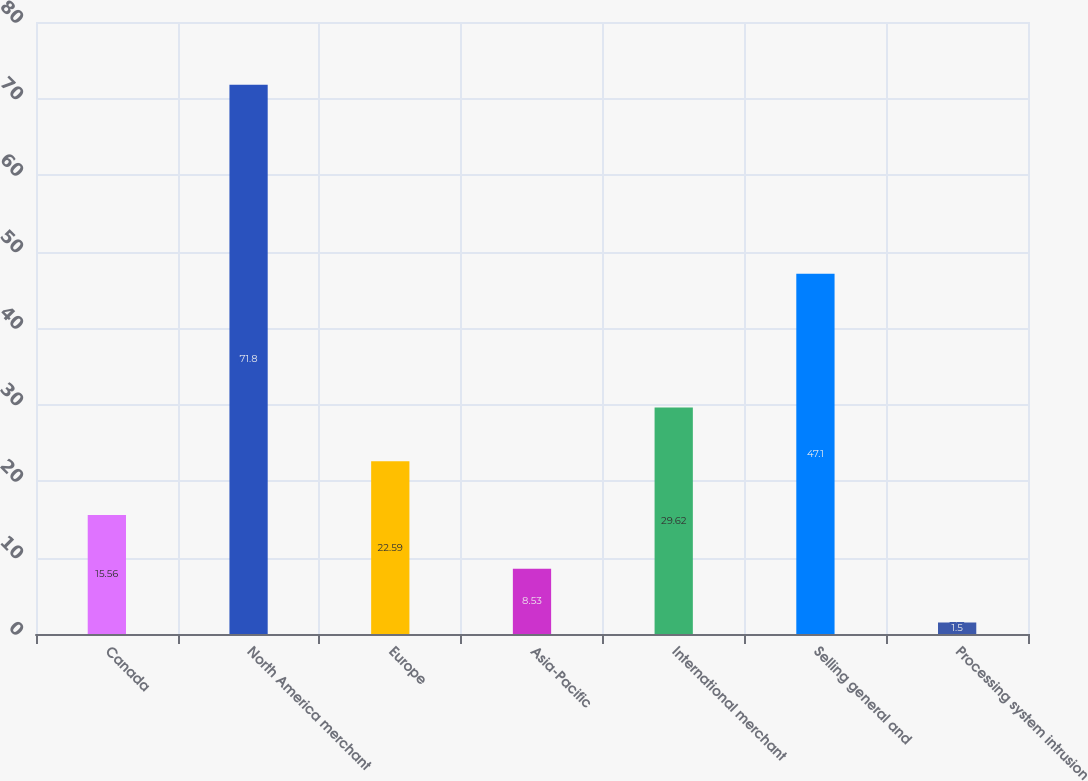Convert chart. <chart><loc_0><loc_0><loc_500><loc_500><bar_chart><fcel>Canada<fcel>North America merchant<fcel>Europe<fcel>Asia-Pacific<fcel>International merchant<fcel>Selling general and<fcel>Processing system intrusion<nl><fcel>15.56<fcel>71.8<fcel>22.59<fcel>8.53<fcel>29.62<fcel>47.1<fcel>1.5<nl></chart> 